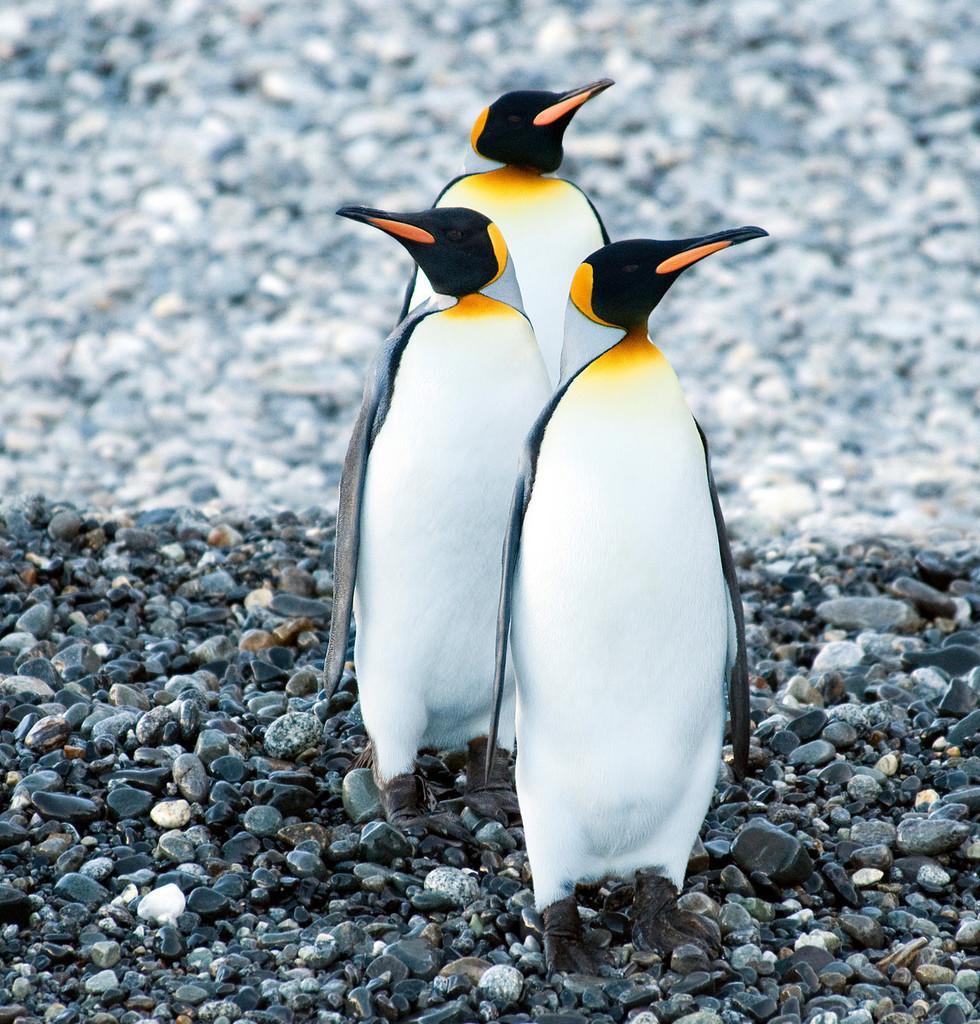Please provide a concise description of this image. In this picture we can see penguins and stones. In the background of the image it is blurry. 